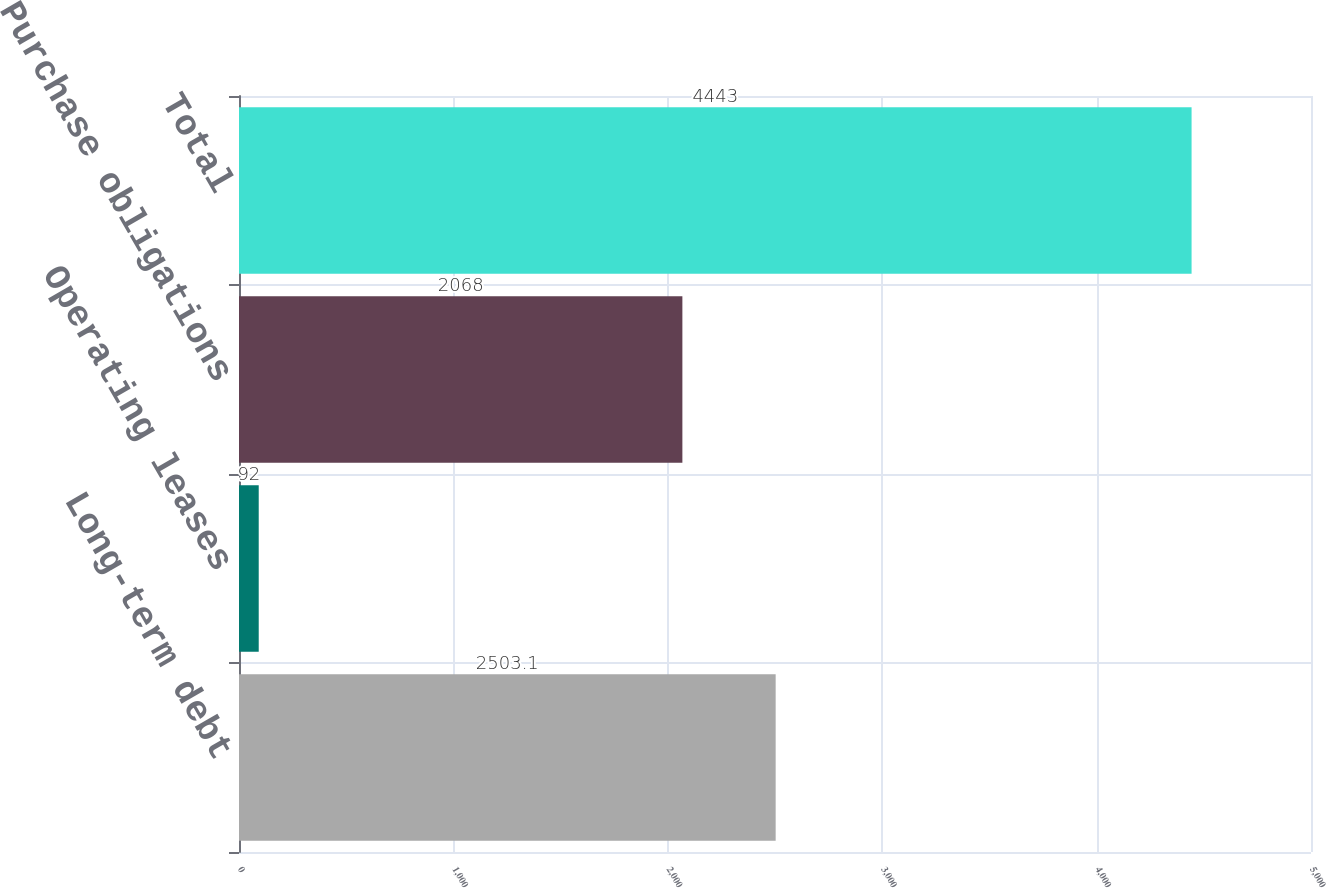Convert chart. <chart><loc_0><loc_0><loc_500><loc_500><bar_chart><fcel>Long-term debt<fcel>Operating leases<fcel>Purchase obligations<fcel>Total<nl><fcel>2503.1<fcel>92<fcel>2068<fcel>4443<nl></chart> 